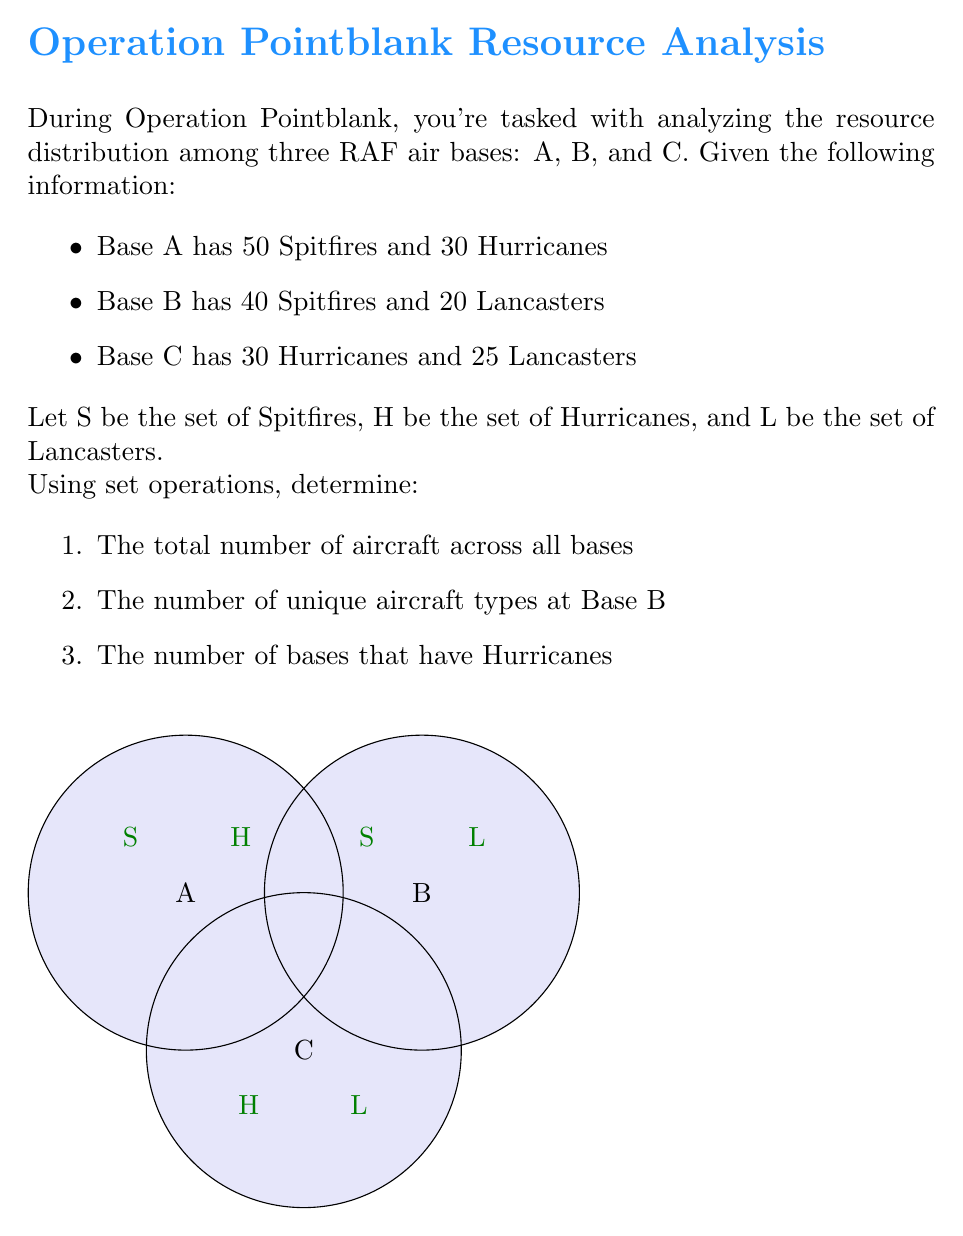Could you help me with this problem? Let's approach this step-by-step:

1. To find the total number of aircraft:
   We need to sum up all aircraft from each base.
   Base A: 50 + 30 = 80
   Base B: 40 + 20 = 60
   Base C: 30 + 25 = 55
   Total: 80 + 60 + 55 = 195

2. To find the number of unique aircraft types at Base B:
   We use the concept of cardinality of a set.
   Base B has Spitfires (S) and Lancasters (L).
   $|S \cup L| = 2$ at Base B

3. To find the number of bases that have Hurricanes:
   We count the bases where set H is not empty.
   Base A has Hurricanes
   Base C has Hurricanes
   Base B does not have Hurricanes
   Total bases with Hurricanes: 2

In set notation:
Let $A$, $B$, and $C$ represent the sets of aircraft at each base.
$A = \{50S, 30H\}$
$B = \{40S, 20L\}$
$C = \{30H, 25L\}$

The total number of aircraft is $|A \cup B \cup C| = 195$

The unique aircraft types at Base B is $|\{S, L\}| = 2$

The number of bases with Hurricanes is $|\{X \in \{A,B,C\} : H \cap X \neq \emptyset\}| = 2$
Answer: 1) 195, 2) 2, 3) 2 